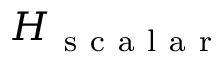<formula> <loc_0><loc_0><loc_500><loc_500>H _ { s c a l a r }</formula> 